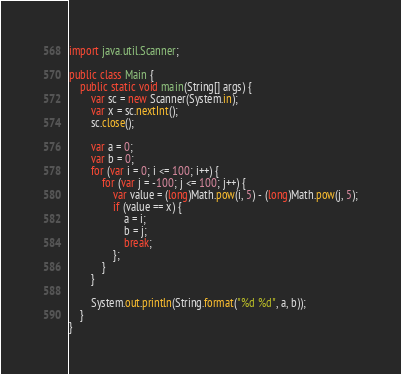<code> <loc_0><loc_0><loc_500><loc_500><_Java_>import java.util.Scanner;

public class Main {
	public static void main(String[] args) {
		var sc = new Scanner(System.in);
		var x = sc.nextInt();
		sc.close();

		var a = 0;
		var b = 0;
		for (var i = 0; i <= 100; i++) {
			for (var j = -100; j <= 100; j++) {
				var value = (long)Math.pow(i, 5) - (long)Math.pow(j, 5);
				if (value == x) {
					a = i;
					b = j;
					break;
				};
			}
		}

		System.out.println(String.format("%d %d", a, b));
	}
}</code> 